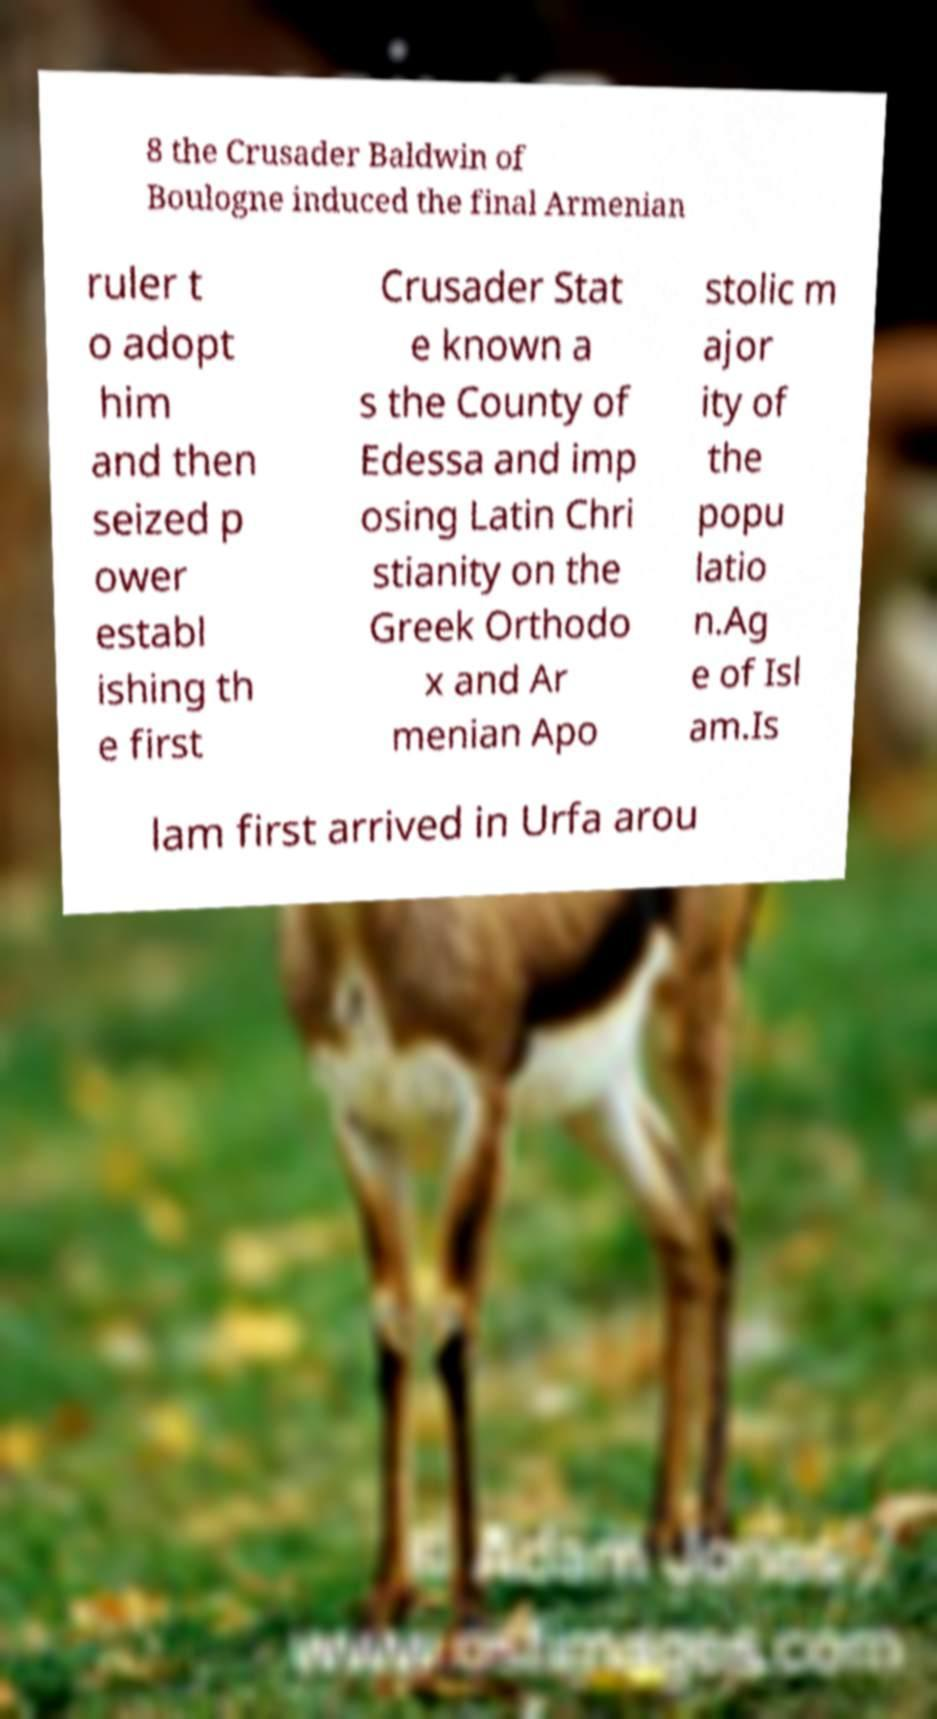Could you extract and type out the text from this image? 8 the Crusader Baldwin of Boulogne induced the final Armenian ruler t o adopt him and then seized p ower establ ishing th e first Crusader Stat e known a s the County of Edessa and imp osing Latin Chri stianity on the Greek Orthodo x and Ar menian Apo stolic m ajor ity of the popu latio n.Ag e of Isl am.Is lam first arrived in Urfa arou 